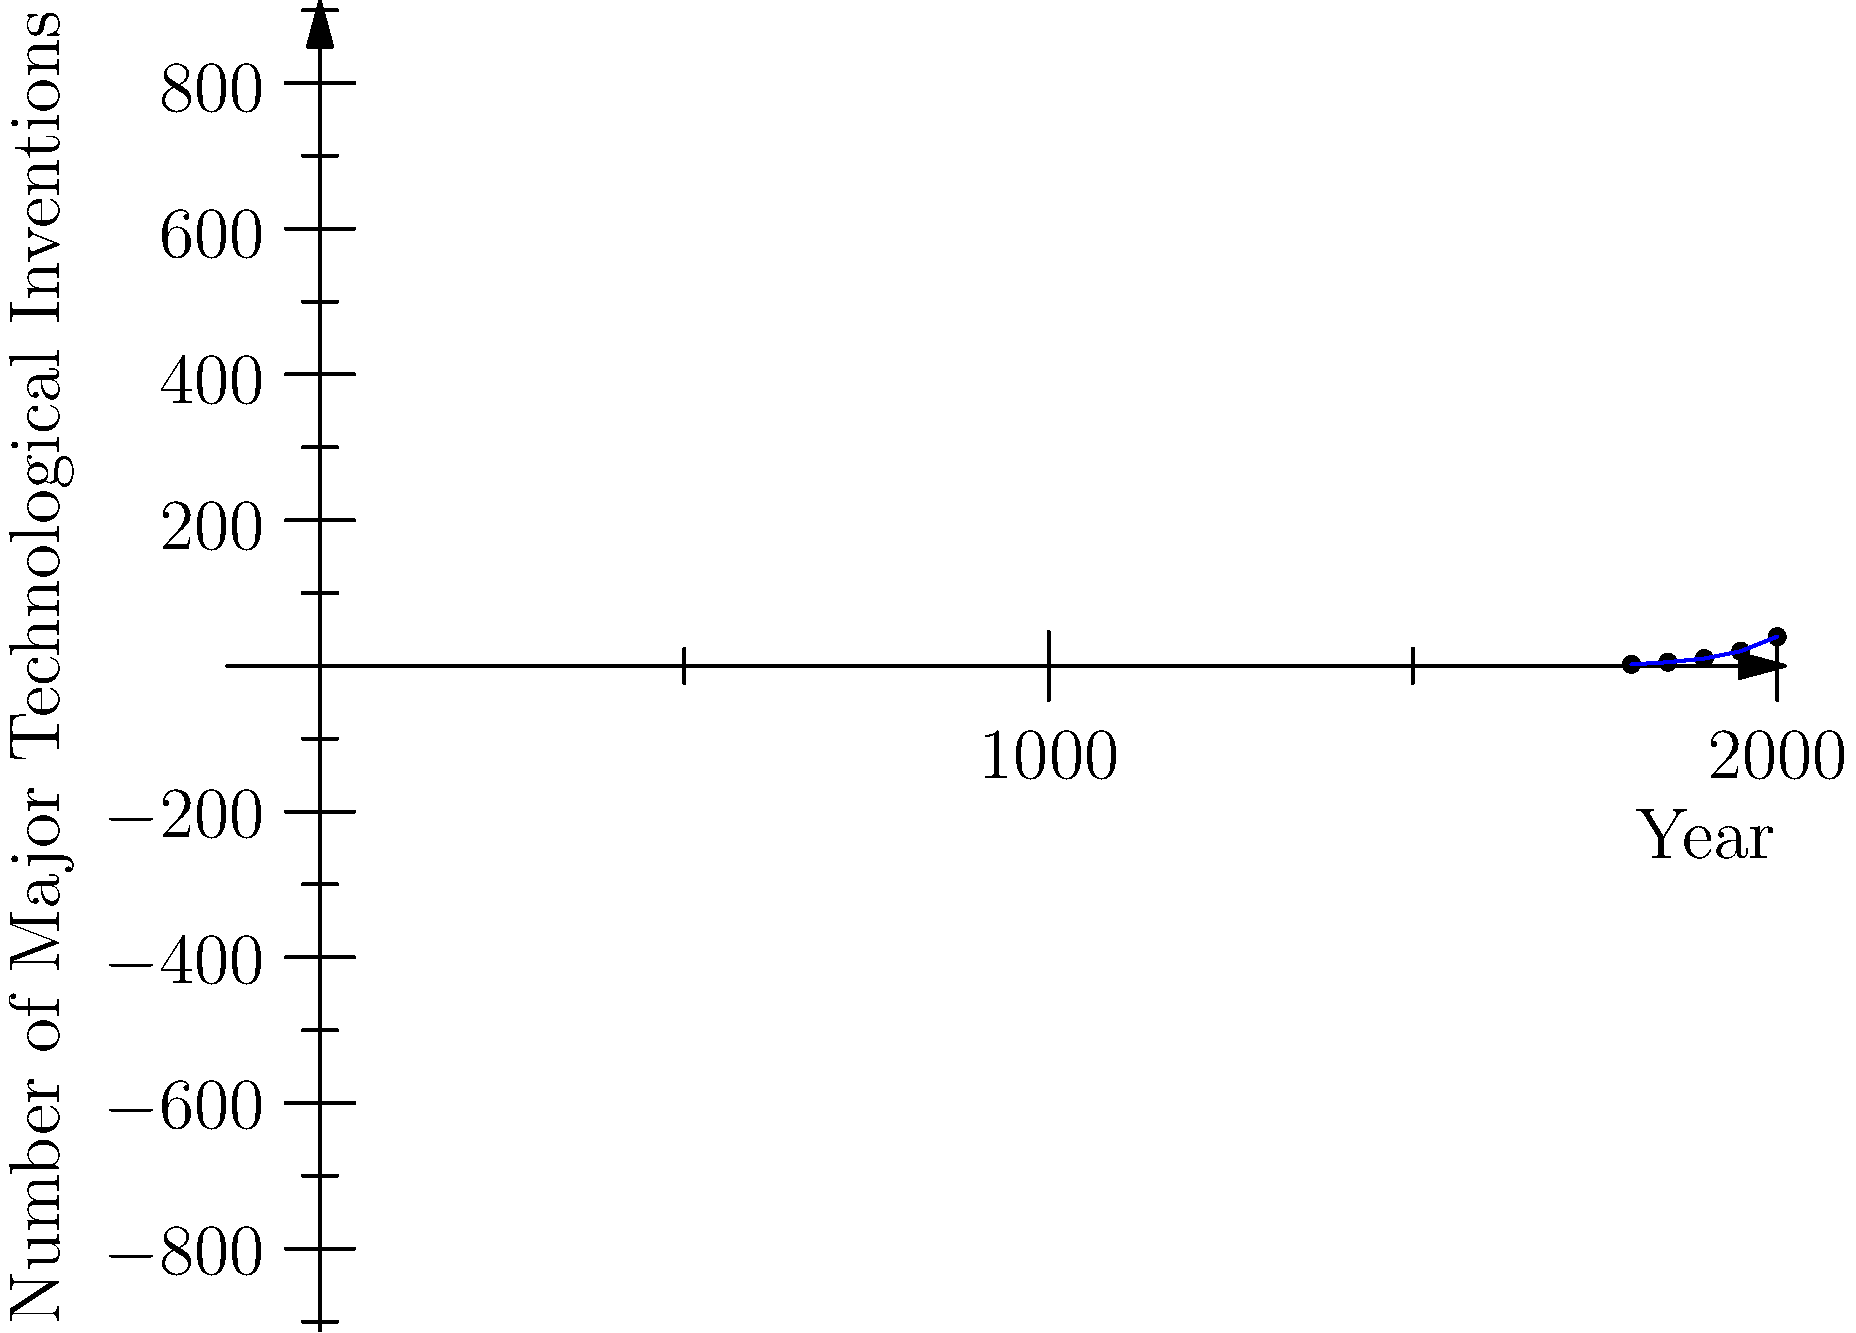As a historian examining technological progress, what trend does this chart reveal about the rate of major technological inventions from 1800 to 2000? How might this trend relate to societal changes during this period? To analyze this chart and its implications:

1. Observe the overall trend: The line shows a clear upward curve, indicating an increase in the number of major technological inventions over time.

2. Rate of change: The slope of the line becomes steeper as time progresses, suggesting an acceleration in the rate of technological innovation.

3. Specific periods:
   - 1800-1850: Relatively slow growth
   - 1850-1900: Slightly faster growth
   - 1900-1950: Significant increase in the rate of innovation
   - 1950-2000: Dramatic acceleration in technological advancements

4. Historical context:
   - Industrial Revolution (late 18th to 19th century): Initial boost in technological innovation
   - Second Industrial Revolution (late 19th to early 20th century): Further acceleration
   - Post-World War II era: Rapid technological progress due to increased research and development

5. Societal implications:
   - Economic changes: Shift from agricultural to industrial to information-based economies
   - Social changes: Urbanization, changes in work patterns, improved living standards
   - Educational changes: Increased emphasis on scientific and technical education
   - Globalization: Faster communication and transportation technologies connecting the world

6. Potential factors contributing to this trend:
   - Cumulative nature of knowledge and technology
   - Increased investment in research and development
   - Improved education and scientific literacy
   - Geopolitical competition (e.g., Space Race, Cold War)

This exponential growth in technological innovation correlates with significant societal transformations, reshaping economies, social structures, and global interactions throughout the 19th and 20th centuries.
Answer: Exponential growth in technological innovation, correlating with rapid societal changes and economic transformations. 